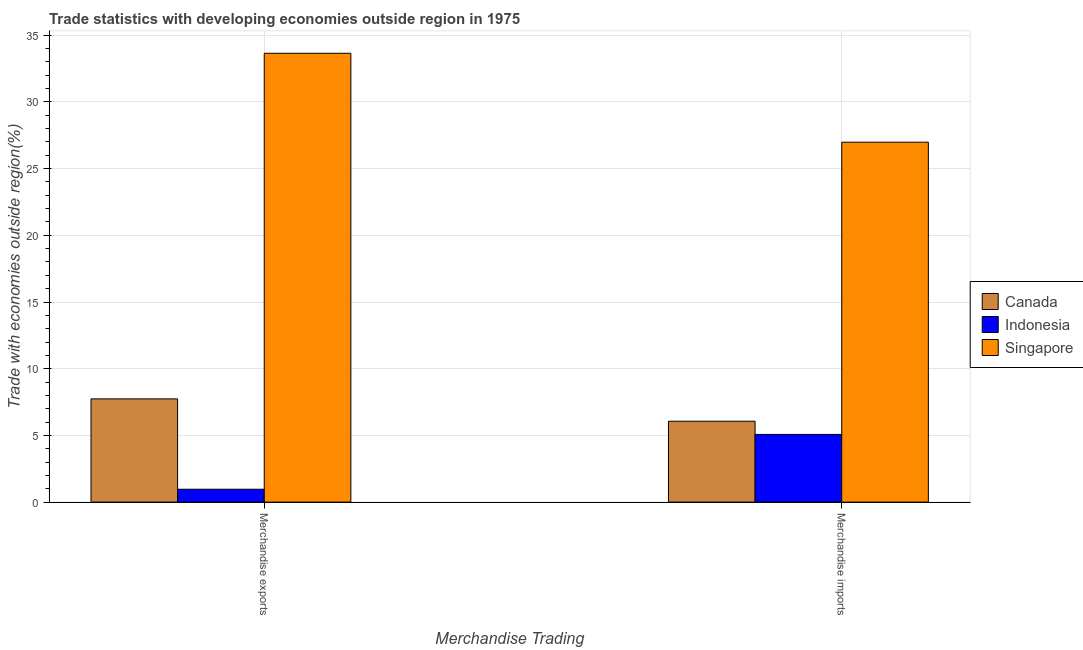Are the number of bars per tick equal to the number of legend labels?
Give a very brief answer. Yes. Are the number of bars on each tick of the X-axis equal?
Keep it short and to the point. Yes. How many bars are there on the 2nd tick from the left?
Offer a very short reply. 3. What is the merchandise exports in Indonesia?
Keep it short and to the point. 0.97. Across all countries, what is the maximum merchandise exports?
Offer a terse response. 33.65. Across all countries, what is the minimum merchandise imports?
Ensure brevity in your answer.  5.07. In which country was the merchandise exports maximum?
Provide a short and direct response. Singapore. What is the total merchandise exports in the graph?
Provide a short and direct response. 42.35. What is the difference between the merchandise imports in Singapore and that in Canada?
Offer a very short reply. 20.92. What is the difference between the merchandise imports in Indonesia and the merchandise exports in Canada?
Offer a very short reply. -2.66. What is the average merchandise imports per country?
Keep it short and to the point. 12.71. What is the difference between the merchandise exports and merchandise imports in Canada?
Provide a short and direct response. 1.67. What is the ratio of the merchandise imports in Singapore to that in Indonesia?
Provide a short and direct response. 5.32. Is the merchandise exports in Indonesia less than that in Canada?
Provide a short and direct response. Yes. In how many countries, is the merchandise exports greater than the average merchandise exports taken over all countries?
Offer a terse response. 1. What does the 3rd bar from the right in Merchandise exports represents?
Provide a succinct answer. Canada. Are all the bars in the graph horizontal?
Your answer should be compact. No. How many countries are there in the graph?
Your response must be concise. 3. Are the values on the major ticks of Y-axis written in scientific E-notation?
Keep it short and to the point. No. How many legend labels are there?
Keep it short and to the point. 3. How are the legend labels stacked?
Your answer should be compact. Vertical. What is the title of the graph?
Your response must be concise. Trade statistics with developing economies outside region in 1975. What is the label or title of the X-axis?
Your response must be concise. Merchandise Trading. What is the label or title of the Y-axis?
Your answer should be compact. Trade with economies outside region(%). What is the Trade with economies outside region(%) of Canada in Merchandise exports?
Ensure brevity in your answer.  7.74. What is the Trade with economies outside region(%) in Indonesia in Merchandise exports?
Provide a short and direct response. 0.97. What is the Trade with economies outside region(%) in Singapore in Merchandise exports?
Your answer should be compact. 33.65. What is the Trade with economies outside region(%) in Canada in Merchandise imports?
Ensure brevity in your answer.  6.06. What is the Trade with economies outside region(%) of Indonesia in Merchandise imports?
Provide a short and direct response. 5.07. What is the Trade with economies outside region(%) of Singapore in Merchandise imports?
Ensure brevity in your answer.  26.98. Across all Merchandise Trading, what is the maximum Trade with economies outside region(%) in Canada?
Ensure brevity in your answer.  7.74. Across all Merchandise Trading, what is the maximum Trade with economies outside region(%) in Indonesia?
Offer a very short reply. 5.07. Across all Merchandise Trading, what is the maximum Trade with economies outside region(%) of Singapore?
Offer a very short reply. 33.65. Across all Merchandise Trading, what is the minimum Trade with economies outside region(%) in Canada?
Give a very brief answer. 6.06. Across all Merchandise Trading, what is the minimum Trade with economies outside region(%) in Indonesia?
Your answer should be compact. 0.97. Across all Merchandise Trading, what is the minimum Trade with economies outside region(%) in Singapore?
Give a very brief answer. 26.98. What is the total Trade with economies outside region(%) of Canada in the graph?
Provide a succinct answer. 13.8. What is the total Trade with economies outside region(%) of Indonesia in the graph?
Your response must be concise. 6.04. What is the total Trade with economies outside region(%) of Singapore in the graph?
Give a very brief answer. 60.63. What is the difference between the Trade with economies outside region(%) in Canada in Merchandise exports and that in Merchandise imports?
Give a very brief answer. 1.67. What is the difference between the Trade with economies outside region(%) in Indonesia in Merchandise exports and that in Merchandise imports?
Your response must be concise. -4.11. What is the difference between the Trade with economies outside region(%) of Singapore in Merchandise exports and that in Merchandise imports?
Offer a terse response. 6.67. What is the difference between the Trade with economies outside region(%) of Canada in Merchandise exports and the Trade with economies outside region(%) of Indonesia in Merchandise imports?
Give a very brief answer. 2.66. What is the difference between the Trade with economies outside region(%) of Canada in Merchandise exports and the Trade with economies outside region(%) of Singapore in Merchandise imports?
Provide a succinct answer. -19.24. What is the difference between the Trade with economies outside region(%) of Indonesia in Merchandise exports and the Trade with economies outside region(%) of Singapore in Merchandise imports?
Your answer should be compact. -26.01. What is the average Trade with economies outside region(%) of Canada per Merchandise Trading?
Make the answer very short. 6.9. What is the average Trade with economies outside region(%) in Indonesia per Merchandise Trading?
Make the answer very short. 3.02. What is the average Trade with economies outside region(%) of Singapore per Merchandise Trading?
Keep it short and to the point. 30.31. What is the difference between the Trade with economies outside region(%) in Canada and Trade with economies outside region(%) in Indonesia in Merchandise exports?
Provide a short and direct response. 6.77. What is the difference between the Trade with economies outside region(%) of Canada and Trade with economies outside region(%) of Singapore in Merchandise exports?
Provide a short and direct response. -25.91. What is the difference between the Trade with economies outside region(%) in Indonesia and Trade with economies outside region(%) in Singapore in Merchandise exports?
Provide a short and direct response. -32.68. What is the difference between the Trade with economies outside region(%) in Canada and Trade with economies outside region(%) in Singapore in Merchandise imports?
Give a very brief answer. -20.92. What is the difference between the Trade with economies outside region(%) in Indonesia and Trade with economies outside region(%) in Singapore in Merchandise imports?
Your answer should be very brief. -21.91. What is the ratio of the Trade with economies outside region(%) in Canada in Merchandise exports to that in Merchandise imports?
Offer a very short reply. 1.28. What is the ratio of the Trade with economies outside region(%) in Indonesia in Merchandise exports to that in Merchandise imports?
Your answer should be compact. 0.19. What is the ratio of the Trade with economies outside region(%) in Singapore in Merchandise exports to that in Merchandise imports?
Offer a very short reply. 1.25. What is the difference between the highest and the second highest Trade with economies outside region(%) of Canada?
Make the answer very short. 1.67. What is the difference between the highest and the second highest Trade with economies outside region(%) in Indonesia?
Offer a very short reply. 4.11. What is the difference between the highest and the second highest Trade with economies outside region(%) in Singapore?
Your response must be concise. 6.67. What is the difference between the highest and the lowest Trade with economies outside region(%) in Canada?
Make the answer very short. 1.67. What is the difference between the highest and the lowest Trade with economies outside region(%) in Indonesia?
Keep it short and to the point. 4.11. What is the difference between the highest and the lowest Trade with economies outside region(%) of Singapore?
Your answer should be very brief. 6.67. 